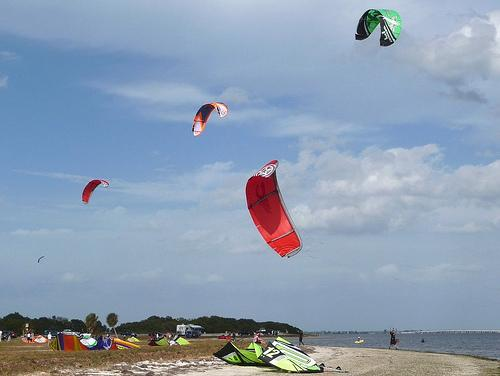The inflatable wing used to fly in which game? paragliding 